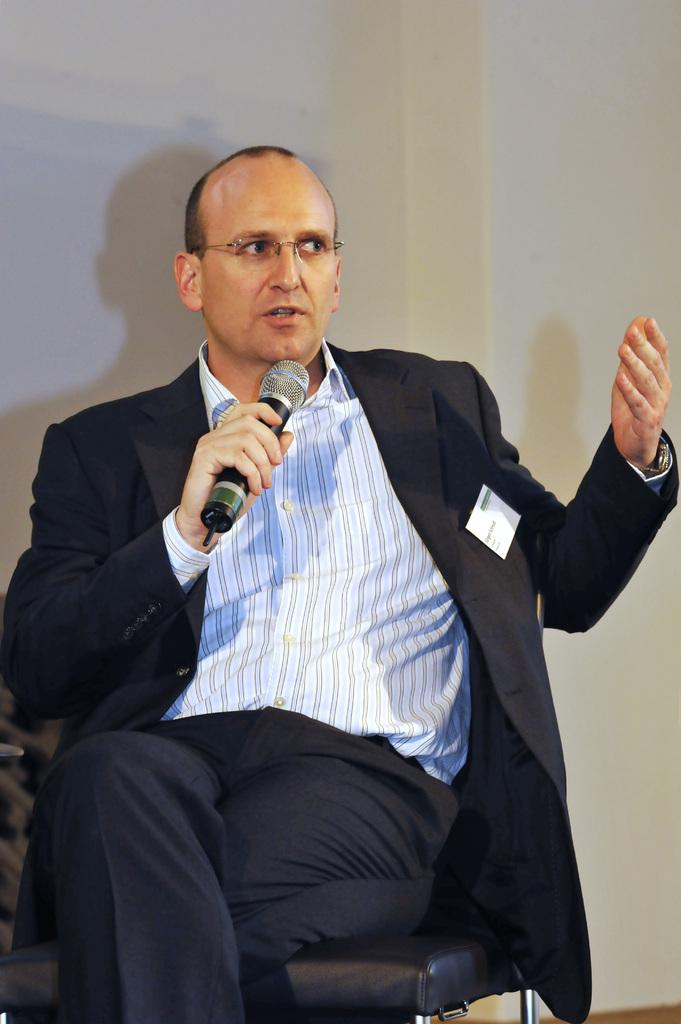Who is the main subject in the image? There is a man in the image. What is the man doing in the image? The man is sitting in the image. What is the man holding in his hand? The man is holding a mic in his hand. What type of pickle is the man eating in the image? There is no pickle present in the image; the man is holding a mic. 